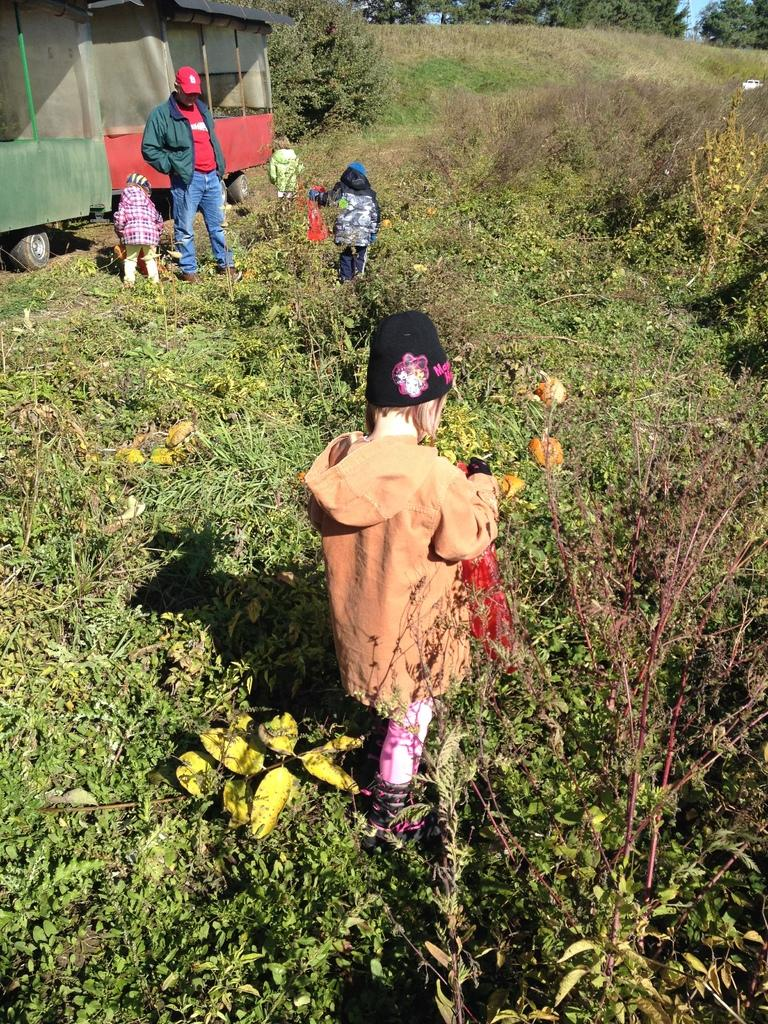What are the people in the image doing? The people in the image are walking on the grass. Can you describe the position of one of the people in the image? There is a person standing in the image. What can be seen in the background of the image? There is a vehicle and trees in the background of the image. What type of flowers can be seen growing near the person standing in the image? There are no flowers visible in the image. Is there a battle taking place in the image? No, there is no battle depicted in the image. 